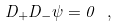Convert formula to latex. <formula><loc_0><loc_0><loc_500><loc_500>D _ { + } D _ { - } \psi = 0 \ ,</formula> 